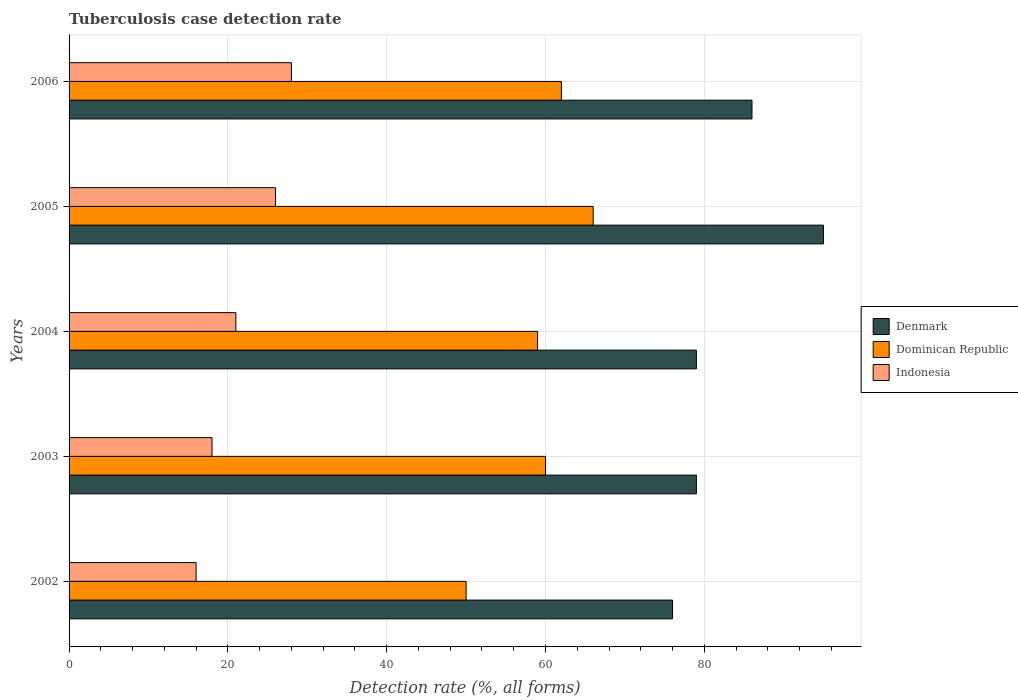How many different coloured bars are there?
Offer a terse response. 3. How many groups of bars are there?
Make the answer very short. 5. Are the number of bars per tick equal to the number of legend labels?
Offer a terse response. Yes. Are the number of bars on each tick of the Y-axis equal?
Your response must be concise. Yes. What is the tuberculosis case detection rate in in Denmark in 2005?
Ensure brevity in your answer.  95. Across all years, what is the maximum tuberculosis case detection rate in in Dominican Republic?
Ensure brevity in your answer.  66. Across all years, what is the minimum tuberculosis case detection rate in in Dominican Republic?
Make the answer very short. 50. What is the total tuberculosis case detection rate in in Dominican Republic in the graph?
Give a very brief answer. 297. What is the difference between the tuberculosis case detection rate in in Denmark in 2004 and that in 2006?
Ensure brevity in your answer.  -7. What is the difference between the tuberculosis case detection rate in in Denmark in 2006 and the tuberculosis case detection rate in in Indonesia in 2002?
Provide a succinct answer. 70. What is the average tuberculosis case detection rate in in Indonesia per year?
Ensure brevity in your answer.  21.8. In the year 2004, what is the difference between the tuberculosis case detection rate in in Denmark and tuberculosis case detection rate in in Dominican Republic?
Give a very brief answer. 20. In how many years, is the tuberculosis case detection rate in in Indonesia greater than 16 %?
Offer a very short reply. 4. What is the ratio of the tuberculosis case detection rate in in Dominican Republic in 2004 to that in 2005?
Provide a short and direct response. 0.89. Is the difference between the tuberculosis case detection rate in in Denmark in 2004 and 2006 greater than the difference between the tuberculosis case detection rate in in Dominican Republic in 2004 and 2006?
Your answer should be very brief. No. What does the 3rd bar from the top in 2006 represents?
Your answer should be compact. Denmark. What does the 2nd bar from the bottom in 2003 represents?
Your answer should be compact. Dominican Republic. Is it the case that in every year, the sum of the tuberculosis case detection rate in in Denmark and tuberculosis case detection rate in in Dominican Republic is greater than the tuberculosis case detection rate in in Indonesia?
Offer a terse response. Yes. Are all the bars in the graph horizontal?
Your response must be concise. Yes. What is the difference between two consecutive major ticks on the X-axis?
Provide a short and direct response. 20. Are the values on the major ticks of X-axis written in scientific E-notation?
Provide a succinct answer. No. Does the graph contain grids?
Provide a short and direct response. Yes. Where does the legend appear in the graph?
Make the answer very short. Center right. How many legend labels are there?
Offer a terse response. 3. How are the legend labels stacked?
Your response must be concise. Vertical. What is the title of the graph?
Provide a succinct answer. Tuberculosis case detection rate. Does "Arab World" appear as one of the legend labels in the graph?
Your answer should be compact. No. What is the label or title of the X-axis?
Your response must be concise. Detection rate (%, all forms). What is the Detection rate (%, all forms) of Dominican Republic in 2002?
Keep it short and to the point. 50. What is the Detection rate (%, all forms) in Denmark in 2003?
Keep it short and to the point. 79. What is the Detection rate (%, all forms) in Indonesia in 2003?
Offer a very short reply. 18. What is the Detection rate (%, all forms) of Denmark in 2004?
Provide a short and direct response. 79. What is the Detection rate (%, all forms) of Denmark in 2005?
Offer a very short reply. 95. What is the Detection rate (%, all forms) in Dominican Republic in 2005?
Ensure brevity in your answer.  66. What is the Detection rate (%, all forms) of Denmark in 2006?
Ensure brevity in your answer.  86. What is the Detection rate (%, all forms) in Dominican Republic in 2006?
Offer a very short reply. 62. Across all years, what is the maximum Detection rate (%, all forms) in Denmark?
Give a very brief answer. 95. Across all years, what is the maximum Detection rate (%, all forms) of Dominican Republic?
Make the answer very short. 66. What is the total Detection rate (%, all forms) in Denmark in the graph?
Your answer should be compact. 415. What is the total Detection rate (%, all forms) in Dominican Republic in the graph?
Keep it short and to the point. 297. What is the total Detection rate (%, all forms) of Indonesia in the graph?
Your answer should be very brief. 109. What is the difference between the Detection rate (%, all forms) in Denmark in 2002 and that in 2003?
Make the answer very short. -3. What is the difference between the Detection rate (%, all forms) of Dominican Republic in 2002 and that in 2003?
Your response must be concise. -10. What is the difference between the Detection rate (%, all forms) of Indonesia in 2002 and that in 2003?
Your answer should be compact. -2. What is the difference between the Detection rate (%, all forms) of Denmark in 2002 and that in 2004?
Keep it short and to the point. -3. What is the difference between the Detection rate (%, all forms) of Denmark in 2002 and that in 2005?
Make the answer very short. -19. What is the difference between the Detection rate (%, all forms) in Denmark in 2002 and that in 2006?
Make the answer very short. -10. What is the difference between the Detection rate (%, all forms) in Dominican Republic in 2002 and that in 2006?
Provide a succinct answer. -12. What is the difference between the Detection rate (%, all forms) in Denmark in 2003 and that in 2005?
Your answer should be very brief. -16. What is the difference between the Detection rate (%, all forms) of Indonesia in 2003 and that in 2005?
Your answer should be very brief. -8. What is the difference between the Detection rate (%, all forms) in Denmark in 2003 and that in 2006?
Provide a short and direct response. -7. What is the difference between the Detection rate (%, all forms) in Indonesia in 2003 and that in 2006?
Your response must be concise. -10. What is the difference between the Detection rate (%, all forms) of Indonesia in 2004 and that in 2005?
Your answer should be very brief. -5. What is the difference between the Detection rate (%, all forms) of Denmark in 2004 and that in 2006?
Provide a succinct answer. -7. What is the difference between the Detection rate (%, all forms) in Indonesia in 2004 and that in 2006?
Provide a succinct answer. -7. What is the difference between the Detection rate (%, all forms) in Indonesia in 2005 and that in 2006?
Your response must be concise. -2. What is the difference between the Detection rate (%, all forms) in Denmark in 2002 and the Detection rate (%, all forms) in Dominican Republic in 2003?
Your answer should be very brief. 16. What is the difference between the Detection rate (%, all forms) in Denmark in 2002 and the Detection rate (%, all forms) in Indonesia in 2003?
Your answer should be very brief. 58. What is the difference between the Detection rate (%, all forms) of Dominican Republic in 2002 and the Detection rate (%, all forms) of Indonesia in 2003?
Your answer should be very brief. 32. What is the difference between the Detection rate (%, all forms) of Denmark in 2002 and the Detection rate (%, all forms) of Indonesia in 2004?
Provide a succinct answer. 55. What is the difference between the Detection rate (%, all forms) in Dominican Republic in 2002 and the Detection rate (%, all forms) in Indonesia in 2004?
Ensure brevity in your answer.  29. What is the difference between the Detection rate (%, all forms) in Denmark in 2002 and the Detection rate (%, all forms) in Dominican Republic in 2005?
Provide a succinct answer. 10. What is the difference between the Detection rate (%, all forms) in Denmark in 2002 and the Detection rate (%, all forms) in Indonesia in 2005?
Provide a short and direct response. 50. What is the difference between the Detection rate (%, all forms) of Dominican Republic in 2002 and the Detection rate (%, all forms) of Indonesia in 2005?
Keep it short and to the point. 24. What is the difference between the Detection rate (%, all forms) of Denmark in 2003 and the Detection rate (%, all forms) of Indonesia in 2004?
Offer a terse response. 58. What is the difference between the Detection rate (%, all forms) in Dominican Republic in 2003 and the Detection rate (%, all forms) in Indonesia in 2004?
Make the answer very short. 39. What is the difference between the Detection rate (%, all forms) in Denmark in 2003 and the Detection rate (%, all forms) in Indonesia in 2006?
Offer a terse response. 51. What is the difference between the Detection rate (%, all forms) in Dominican Republic in 2004 and the Detection rate (%, all forms) in Indonesia in 2006?
Provide a short and direct response. 31. What is the difference between the Detection rate (%, all forms) in Denmark in 2005 and the Detection rate (%, all forms) in Dominican Republic in 2006?
Offer a very short reply. 33. What is the difference between the Detection rate (%, all forms) of Denmark in 2005 and the Detection rate (%, all forms) of Indonesia in 2006?
Keep it short and to the point. 67. What is the difference between the Detection rate (%, all forms) in Dominican Republic in 2005 and the Detection rate (%, all forms) in Indonesia in 2006?
Make the answer very short. 38. What is the average Detection rate (%, all forms) of Denmark per year?
Offer a terse response. 83. What is the average Detection rate (%, all forms) in Dominican Republic per year?
Give a very brief answer. 59.4. What is the average Detection rate (%, all forms) of Indonesia per year?
Provide a short and direct response. 21.8. In the year 2003, what is the difference between the Detection rate (%, all forms) in Denmark and Detection rate (%, all forms) in Dominican Republic?
Give a very brief answer. 19. In the year 2003, what is the difference between the Detection rate (%, all forms) in Dominican Republic and Detection rate (%, all forms) in Indonesia?
Keep it short and to the point. 42. In the year 2004, what is the difference between the Detection rate (%, all forms) in Denmark and Detection rate (%, all forms) in Dominican Republic?
Your response must be concise. 20. In the year 2005, what is the difference between the Detection rate (%, all forms) of Denmark and Detection rate (%, all forms) of Dominican Republic?
Give a very brief answer. 29. In the year 2005, what is the difference between the Detection rate (%, all forms) in Dominican Republic and Detection rate (%, all forms) in Indonesia?
Give a very brief answer. 40. In the year 2006, what is the difference between the Detection rate (%, all forms) in Dominican Republic and Detection rate (%, all forms) in Indonesia?
Keep it short and to the point. 34. What is the ratio of the Detection rate (%, all forms) of Denmark in 2002 to that in 2003?
Make the answer very short. 0.96. What is the ratio of the Detection rate (%, all forms) in Dominican Republic in 2002 to that in 2003?
Ensure brevity in your answer.  0.83. What is the ratio of the Detection rate (%, all forms) in Indonesia in 2002 to that in 2003?
Your answer should be compact. 0.89. What is the ratio of the Detection rate (%, all forms) in Denmark in 2002 to that in 2004?
Ensure brevity in your answer.  0.96. What is the ratio of the Detection rate (%, all forms) in Dominican Republic in 2002 to that in 2004?
Provide a succinct answer. 0.85. What is the ratio of the Detection rate (%, all forms) of Indonesia in 2002 to that in 2004?
Offer a very short reply. 0.76. What is the ratio of the Detection rate (%, all forms) in Denmark in 2002 to that in 2005?
Keep it short and to the point. 0.8. What is the ratio of the Detection rate (%, all forms) of Dominican Republic in 2002 to that in 2005?
Your answer should be very brief. 0.76. What is the ratio of the Detection rate (%, all forms) of Indonesia in 2002 to that in 2005?
Your answer should be compact. 0.62. What is the ratio of the Detection rate (%, all forms) of Denmark in 2002 to that in 2006?
Your response must be concise. 0.88. What is the ratio of the Detection rate (%, all forms) in Dominican Republic in 2002 to that in 2006?
Provide a short and direct response. 0.81. What is the ratio of the Detection rate (%, all forms) of Dominican Republic in 2003 to that in 2004?
Make the answer very short. 1.02. What is the ratio of the Detection rate (%, all forms) in Indonesia in 2003 to that in 2004?
Your answer should be very brief. 0.86. What is the ratio of the Detection rate (%, all forms) of Denmark in 2003 to that in 2005?
Offer a very short reply. 0.83. What is the ratio of the Detection rate (%, all forms) of Dominican Republic in 2003 to that in 2005?
Make the answer very short. 0.91. What is the ratio of the Detection rate (%, all forms) of Indonesia in 2003 to that in 2005?
Make the answer very short. 0.69. What is the ratio of the Detection rate (%, all forms) in Denmark in 2003 to that in 2006?
Keep it short and to the point. 0.92. What is the ratio of the Detection rate (%, all forms) of Indonesia in 2003 to that in 2006?
Give a very brief answer. 0.64. What is the ratio of the Detection rate (%, all forms) of Denmark in 2004 to that in 2005?
Offer a very short reply. 0.83. What is the ratio of the Detection rate (%, all forms) of Dominican Republic in 2004 to that in 2005?
Keep it short and to the point. 0.89. What is the ratio of the Detection rate (%, all forms) in Indonesia in 2004 to that in 2005?
Offer a terse response. 0.81. What is the ratio of the Detection rate (%, all forms) of Denmark in 2004 to that in 2006?
Make the answer very short. 0.92. What is the ratio of the Detection rate (%, all forms) in Dominican Republic in 2004 to that in 2006?
Make the answer very short. 0.95. What is the ratio of the Detection rate (%, all forms) of Indonesia in 2004 to that in 2006?
Offer a very short reply. 0.75. What is the ratio of the Detection rate (%, all forms) in Denmark in 2005 to that in 2006?
Keep it short and to the point. 1.1. What is the ratio of the Detection rate (%, all forms) in Dominican Republic in 2005 to that in 2006?
Ensure brevity in your answer.  1.06. What is the difference between the highest and the second highest Detection rate (%, all forms) of Denmark?
Give a very brief answer. 9. What is the difference between the highest and the second highest Detection rate (%, all forms) in Dominican Republic?
Provide a short and direct response. 4. What is the difference between the highest and the lowest Detection rate (%, all forms) in Dominican Republic?
Offer a terse response. 16. What is the difference between the highest and the lowest Detection rate (%, all forms) of Indonesia?
Make the answer very short. 12. 